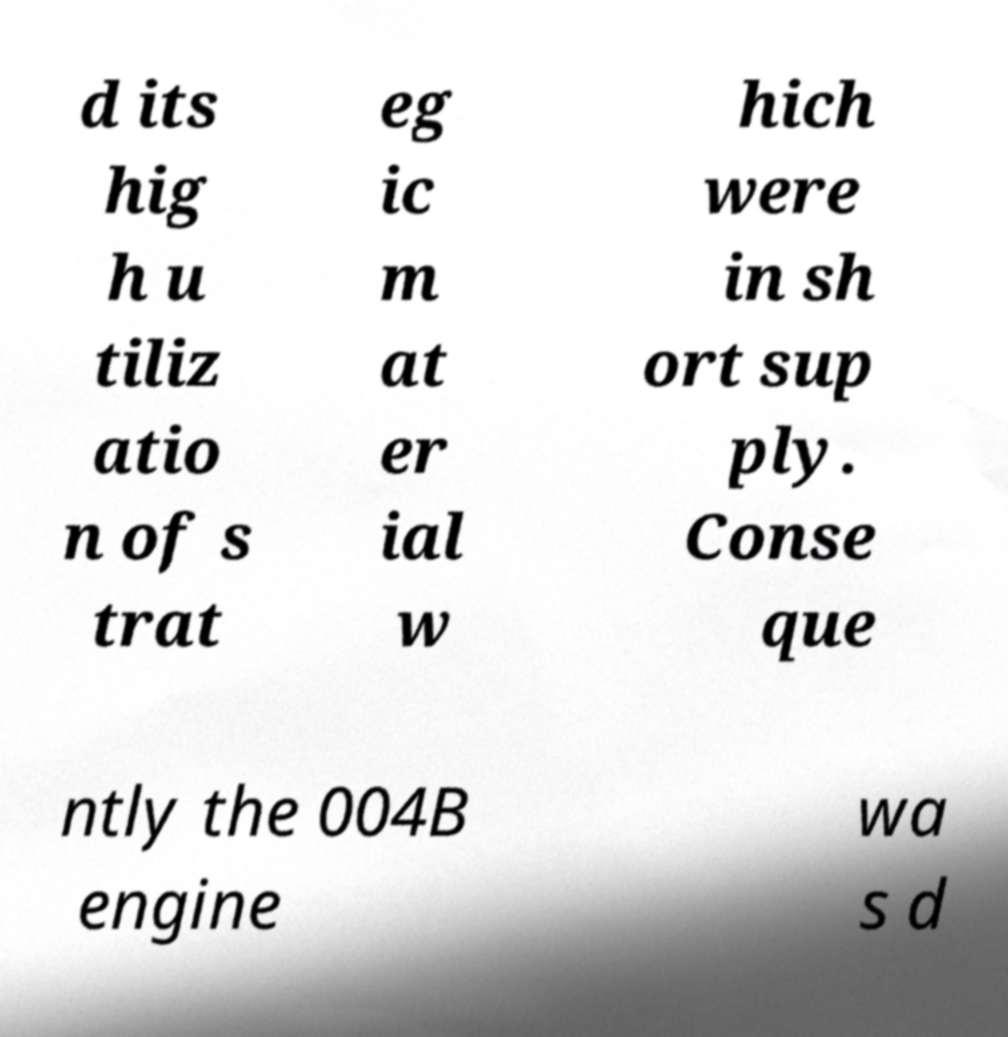I need the written content from this picture converted into text. Can you do that? d its hig h u tiliz atio n of s trat eg ic m at er ial w hich were in sh ort sup ply. Conse que ntly the 004B engine wa s d 